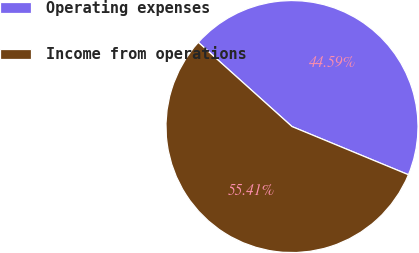<chart> <loc_0><loc_0><loc_500><loc_500><pie_chart><fcel>Operating expenses<fcel>Income from operations<nl><fcel>44.59%<fcel>55.41%<nl></chart> 